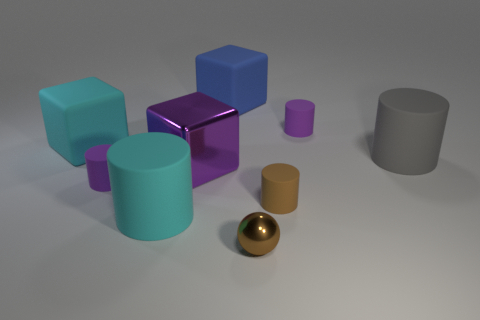What shape is the other thing that is the same color as the tiny metal thing? The object sharing the same color as the tiny metal item, which appears to be a small golden sphere, is a small cylinder. This cylinder, like the sphere, displays a shiny surface and is also placed prominently among other geometric shapes. 